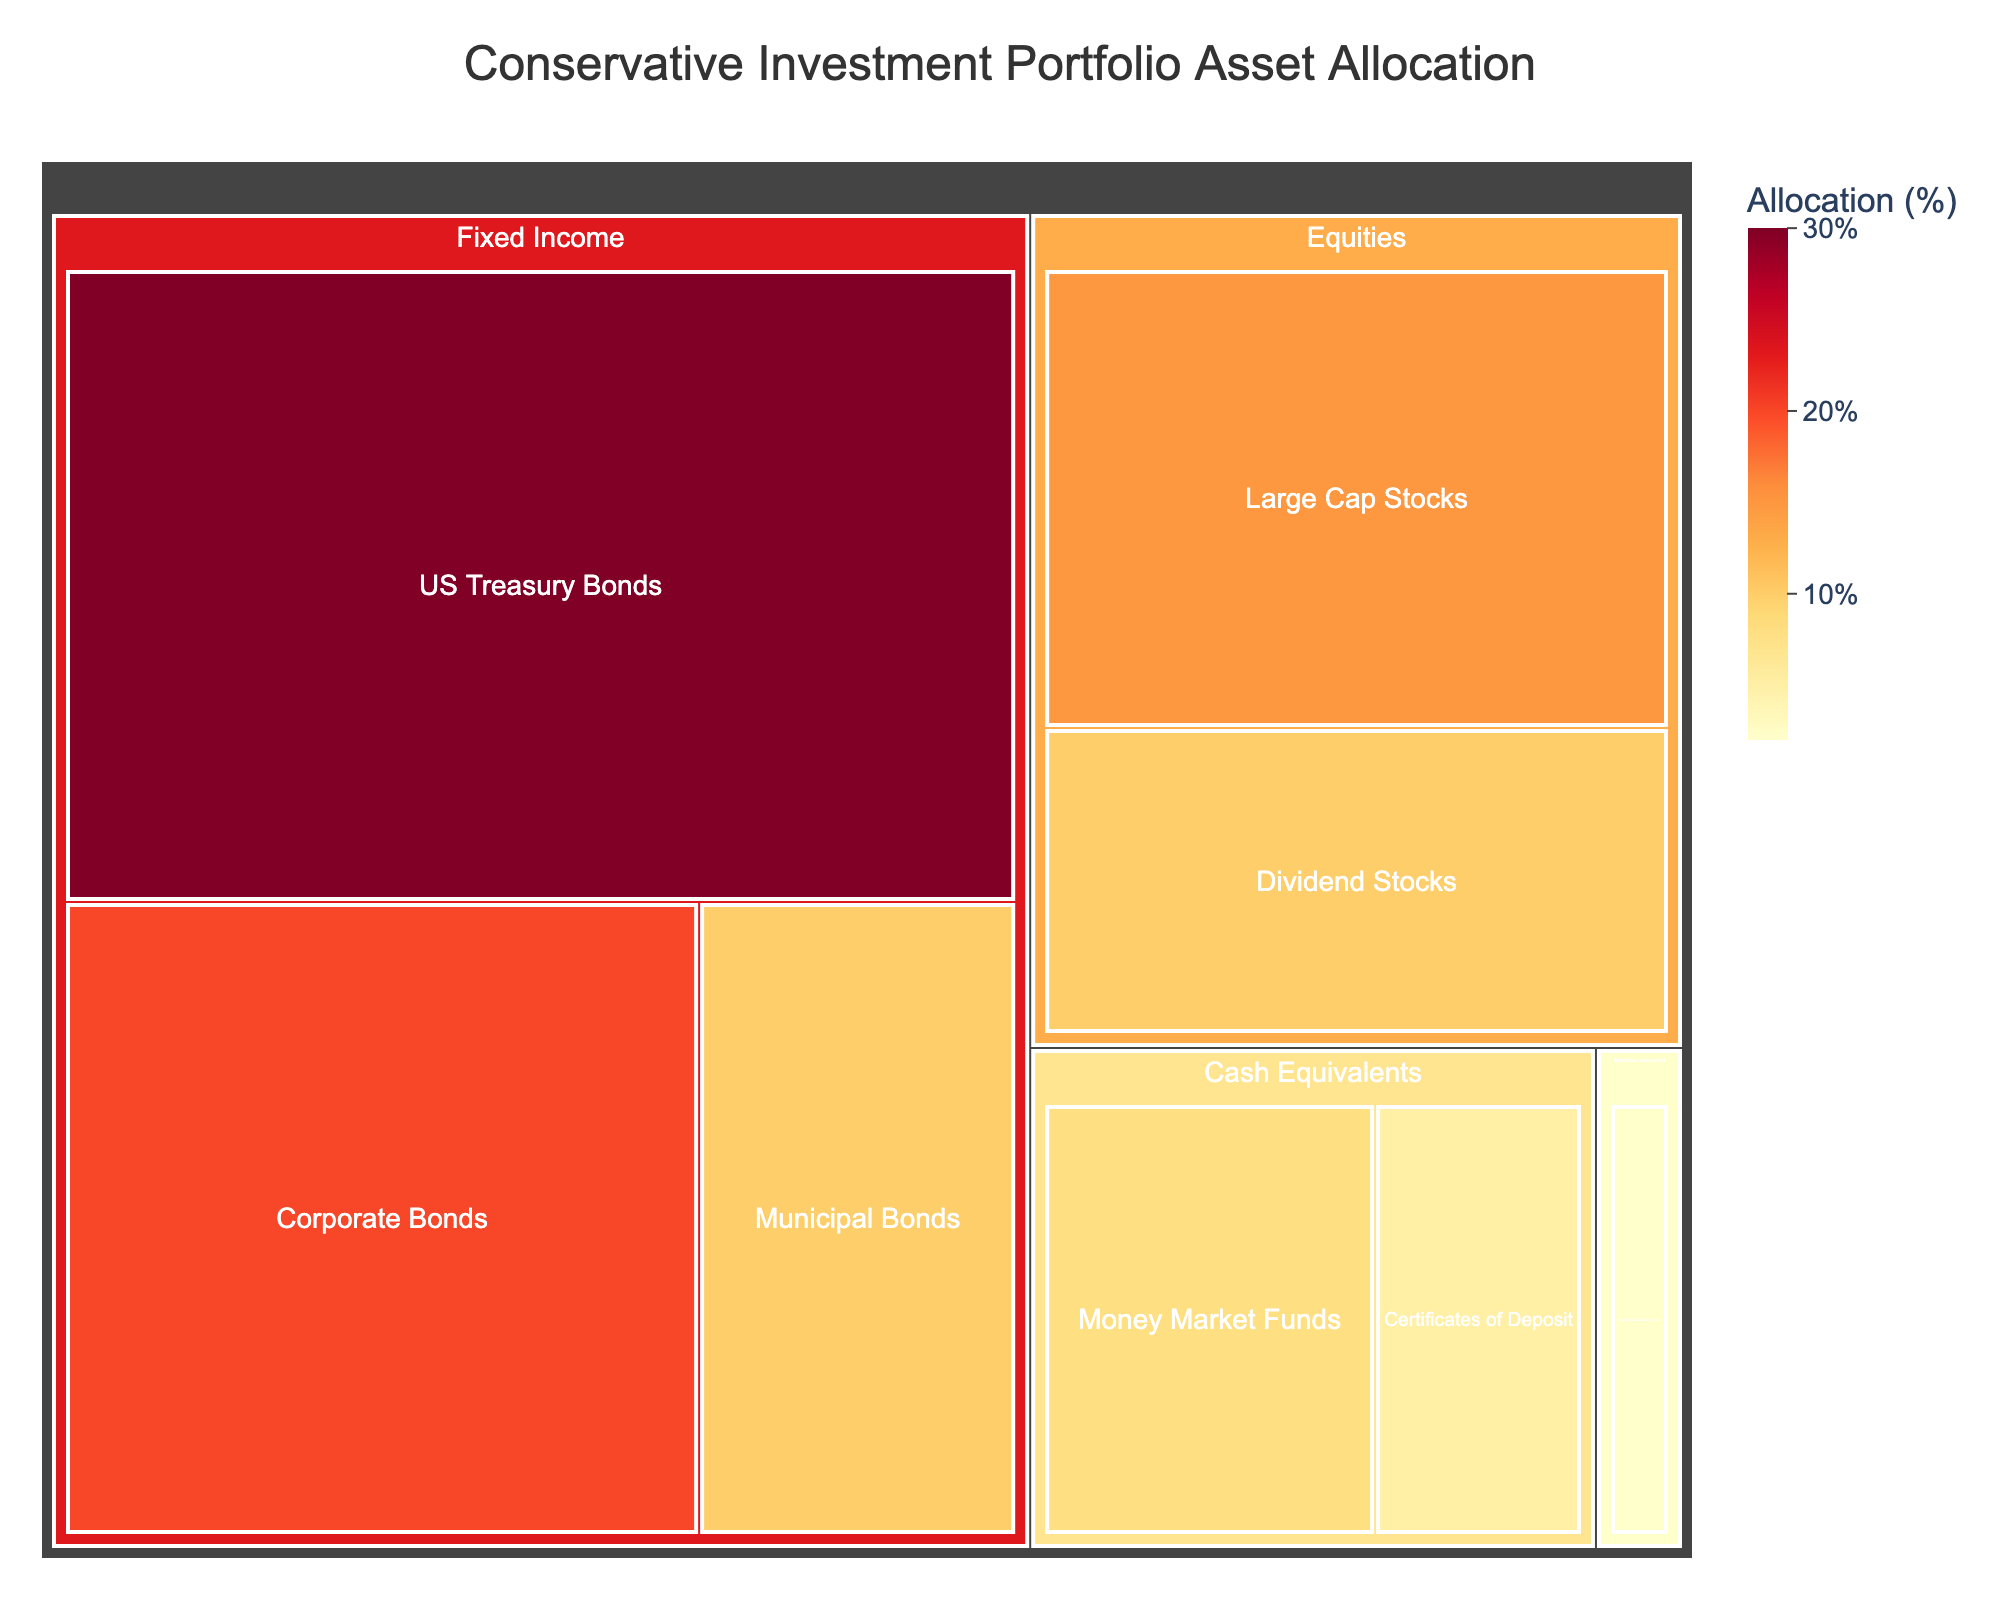What is the title of the figure? The title is displayed prominently at the top center of the figure. It serves as an introduction and provides context to the viewer about what the plot represents.
Answer: Conservative Investment Portfolio Asset Allocation Which subcategory under Fixed Income has the smallest allocation? Under Fixed Income, the subcategories are US Treasury Bonds, Corporate Bonds, and Municipal Bonds. Comparing their values, Municipal Bonds has the smallest allocation.
Answer: Municipal Bonds What total percentage of the portfolio is allocated to Fixed Income? Sum the allocation percentages of all subcategories under Fixed Income: 30 (US Treasury Bonds) + 20 (Corporate Bonds) + 10 (Municipal Bonds) = 60.
Answer: 60% Is the allocation for Corporate Bonds higher than that for Large Cap Stocks? Compare the values: Corporate Bonds (20) and Large Cap Stocks (15). Corporate Bonds have a higher allocation than Large Cap Stocks.
Answer: Yes Which has a higher allocation: Cash Equivalents or Alternative Investments? Sum the allocations for subcategories under each category. Cash Equivalents: 8 (Money Market Funds) + 5 (Certificates of Deposit) = 13, Alternative Investments: 2 (Real Estate Investment Trusts). Therefore, Cash Equivalents have a higher allocation.
Answer: Cash Equivalents What is the percentage difference between the highest and lowest allocations within Fixed Income subcategories? The highest allocation in Fixed Income is US Treasury Bonds (30) and the lowest is Municipal Bonds (10). The percentage difference is calculated as 30 - 10 = 20.
Answer: 20% How much more is allocated to Large Cap Stocks compared to Certificates of Deposit? Compare the values: Large Cap Stocks (15) and Certificates of Deposit (5). The difference is 15 - 5 = 10.
Answer: 10 What is the average allocation percentage for subcategories under Fixed Income? Sum the allocations of Fixed Income subcategories (US Treasury Bonds: 30, Corporate Bonds: 20, Municipal Bonds: 10) and divide by the number of subcategories (3): (30 + 20 + 10) / 3 = 20.
Answer: 20% Which category has the largest allocation in the conservative investment portfolio? Visually, the largest allocation block in the treemap belongs to Fixed Income. Its cumulative subcategory allocations are also the highest at 60%.
Answer: Fixed Income What's the combined allocation percentage for all Equity subcategories? Sum the allocations of the Equity subcategories: 15 (Large Cap Stocks) + 10 (Dividend Stocks) = 25.
Answer: 25% 